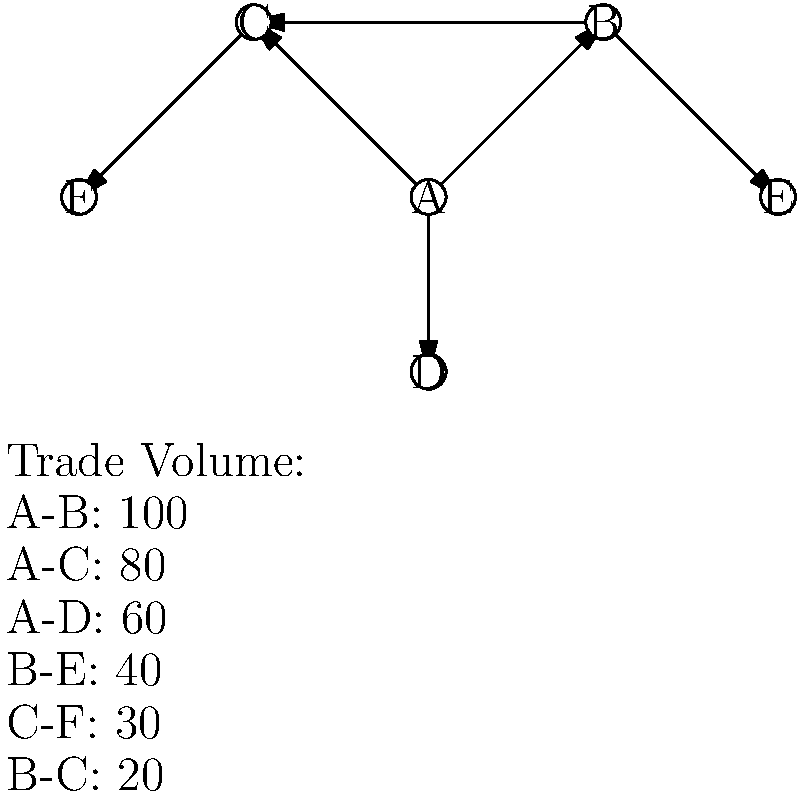In the given historical global trade network diagram, which node represents the key trade hub based on the total volume of trade connections? To identify the key trade hub in this historical global network diagram, we need to analyze the trade connections and volumes for each node:

1. Node A:
   - Connection to B: 100
   - Connection to C: 80
   - Connection to D: 60
   Total volume for A: 100 + 80 + 60 = 240

2. Node B:
   - Connection to A: 100
   - Connection to E: 40
   - Connection to C: 20
   Total volume for B: 100 + 40 + 20 = 160

3. Node C:
   - Connection to A: 80
   - Connection to F: 30
   - Connection to B: 20
   Total volume for C: 80 + 30 + 20 = 130

4. Node D:
   - Connection to A: 60
   Total volume for D: 60

5. Node E:
   - Connection to B: 40
   Total volume for E: 40

6. Node F:
   - Connection to C: 30
   Total volume for F: 30

Comparing the total trade volumes:
A: 240
B: 160
C: 130
D: 60
E: 40
F: 30

Node A has the highest total trade volume (240), making it the key trade hub in this historical global network.
Answer: Node A 